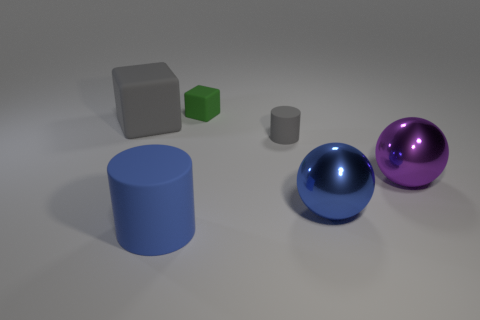How many things are either gray things or big blue objects right of the blue matte object?
Provide a succinct answer. 3. Is there another object of the same shape as the large purple metallic thing?
Offer a very short reply. Yes. There is a cylinder in front of the metallic thing that is in front of the purple shiny object; what size is it?
Provide a short and direct response. Large. Is the big rubber cube the same color as the tiny cylinder?
Keep it short and to the point. Yes. What number of shiny things are either small objects or big red objects?
Provide a succinct answer. 0. What number of tiny purple cylinders are there?
Provide a succinct answer. 0. Are the large thing in front of the big blue ball and the cylinder behind the large cylinder made of the same material?
Ensure brevity in your answer.  Yes. The other large metallic object that is the same shape as the purple object is what color?
Ensure brevity in your answer.  Blue. The blue thing on the right side of the tiny rubber thing that is behind the gray rubber cube is made of what material?
Your answer should be very brief. Metal. Is the shape of the thing on the right side of the big blue sphere the same as the large blue thing on the right side of the gray rubber cylinder?
Keep it short and to the point. Yes. 